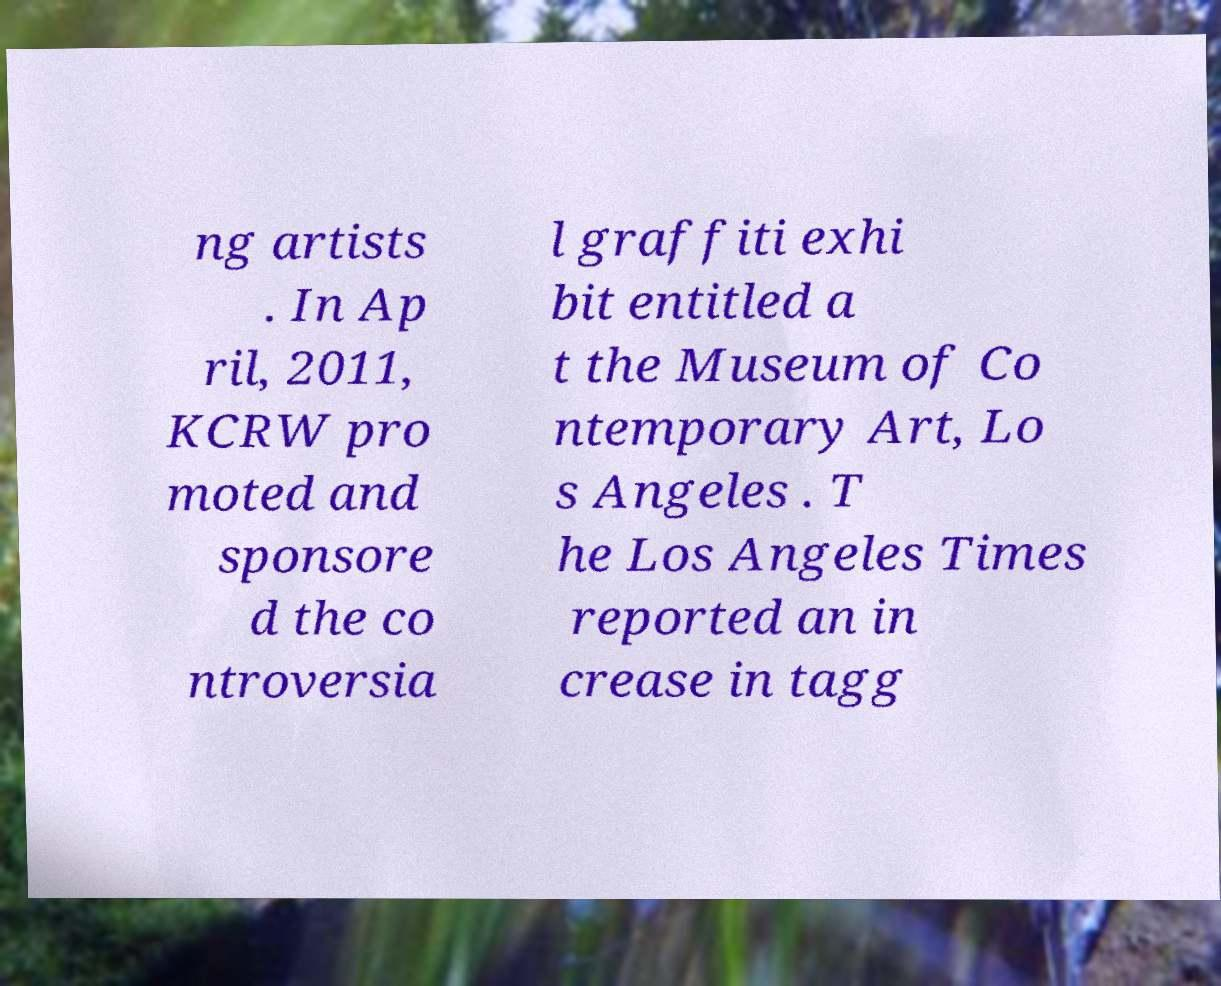Please read and relay the text visible in this image. What does it say? ng artists . In Ap ril, 2011, KCRW pro moted and sponsore d the co ntroversia l graffiti exhi bit entitled a t the Museum of Co ntemporary Art, Lo s Angeles . T he Los Angeles Times reported an in crease in tagg 